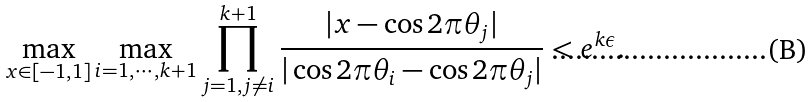<formula> <loc_0><loc_0><loc_500><loc_500>\max _ { x \in [ - 1 , 1 ] } \max _ { i = 1 , \cdots , k + 1 } \prod _ { j = 1 , j \neq i } ^ { k + 1 } \frac { | x - \cos 2 \pi \theta _ { j } | } { | \cos 2 \pi \theta _ { i } - \cos 2 \pi \theta _ { j } | } < e ^ { k \epsilon } .</formula> 